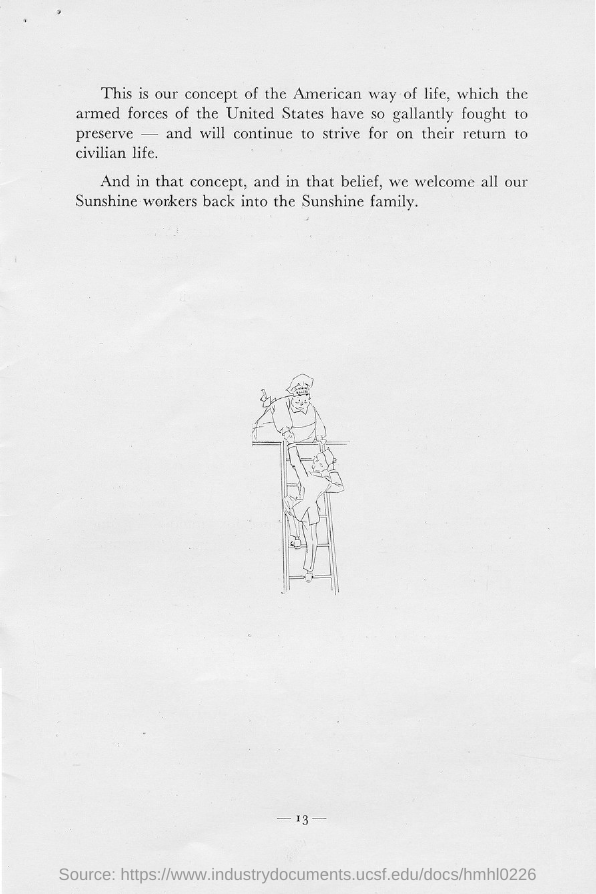Draw attention to some important aspects in this diagram. The page number mentioned in this document is -13-.. 